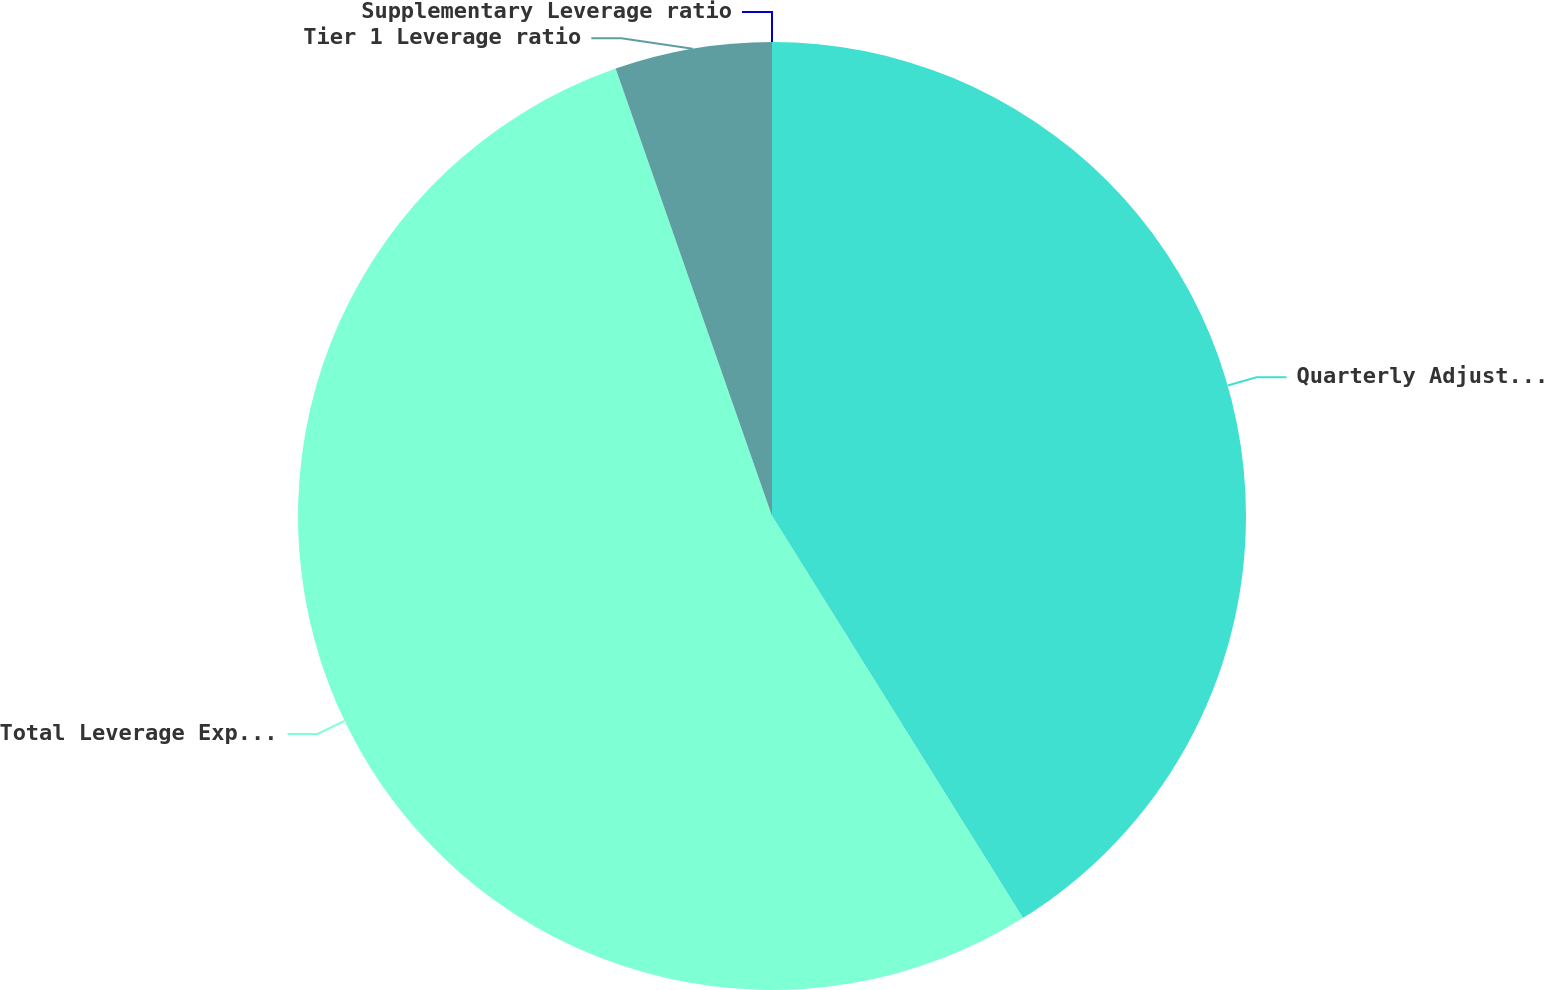<chart> <loc_0><loc_0><loc_500><loc_500><pie_chart><fcel>Quarterly Adjusted Average<fcel>Total Leverage Exposure^(4)<fcel>Tier 1 Leverage ratio<fcel>Supplementary Leverage ratio<nl><fcel>41.12%<fcel>53.53%<fcel>5.35%<fcel>0.0%<nl></chart> 